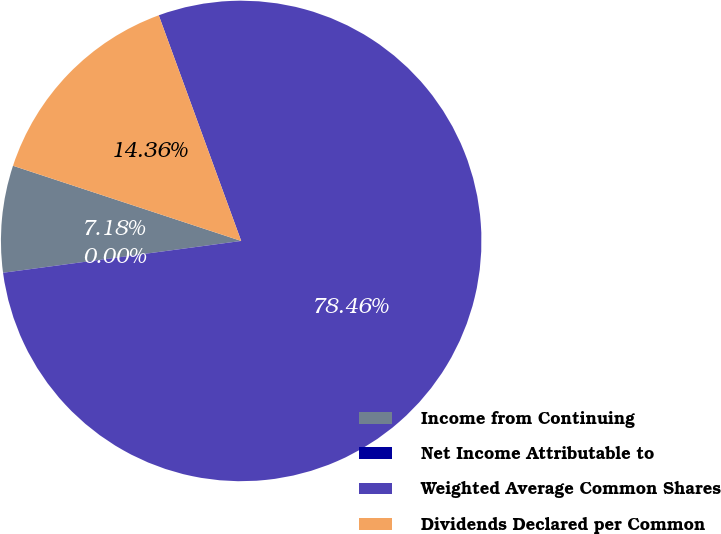<chart> <loc_0><loc_0><loc_500><loc_500><pie_chart><fcel>Income from Continuing<fcel>Net Income Attributable to<fcel>Weighted Average Common Shares<fcel>Dividends Declared per Common<nl><fcel>7.18%<fcel>0.0%<fcel>78.46%<fcel>14.36%<nl></chart> 